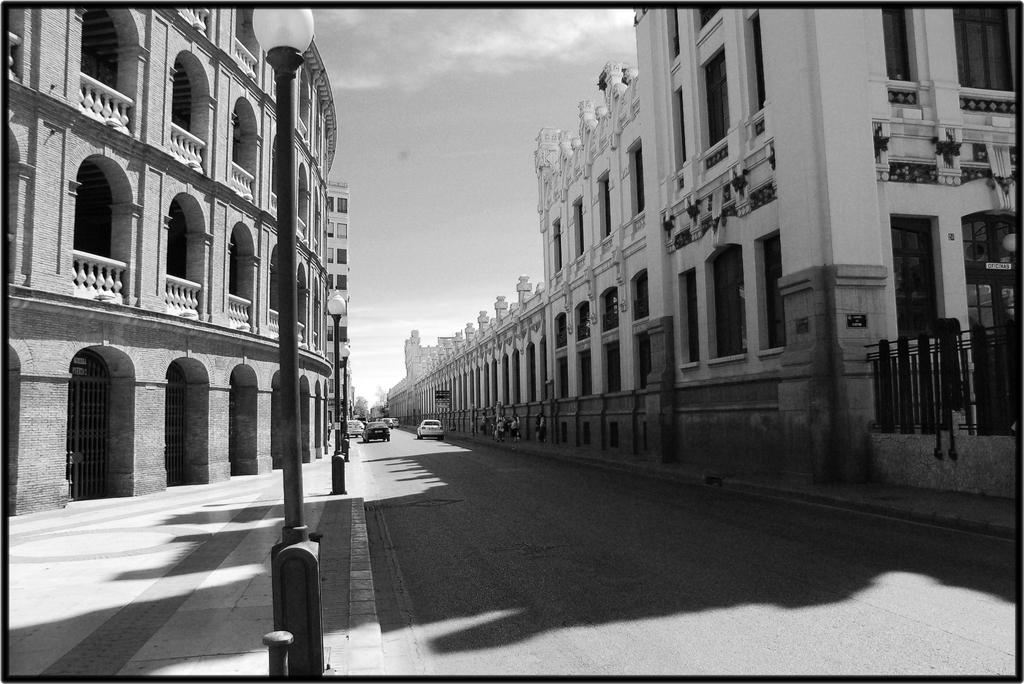What type of structures can be seen in the image? There are buildings in the image. What can be found illuminating the scene in the image? Street lights are present in the image. What mode of transportation can be seen on the road in the image? Vehicles are visible on the road in the image. What part of the natural environment is visible in the image? The sky is visible in the background of the image. What is the color scheme of the image? The image is black and white in color. Can you see a face in the circle on the side of the building in the image? There is no circle or face present on the side of any building in the image. 